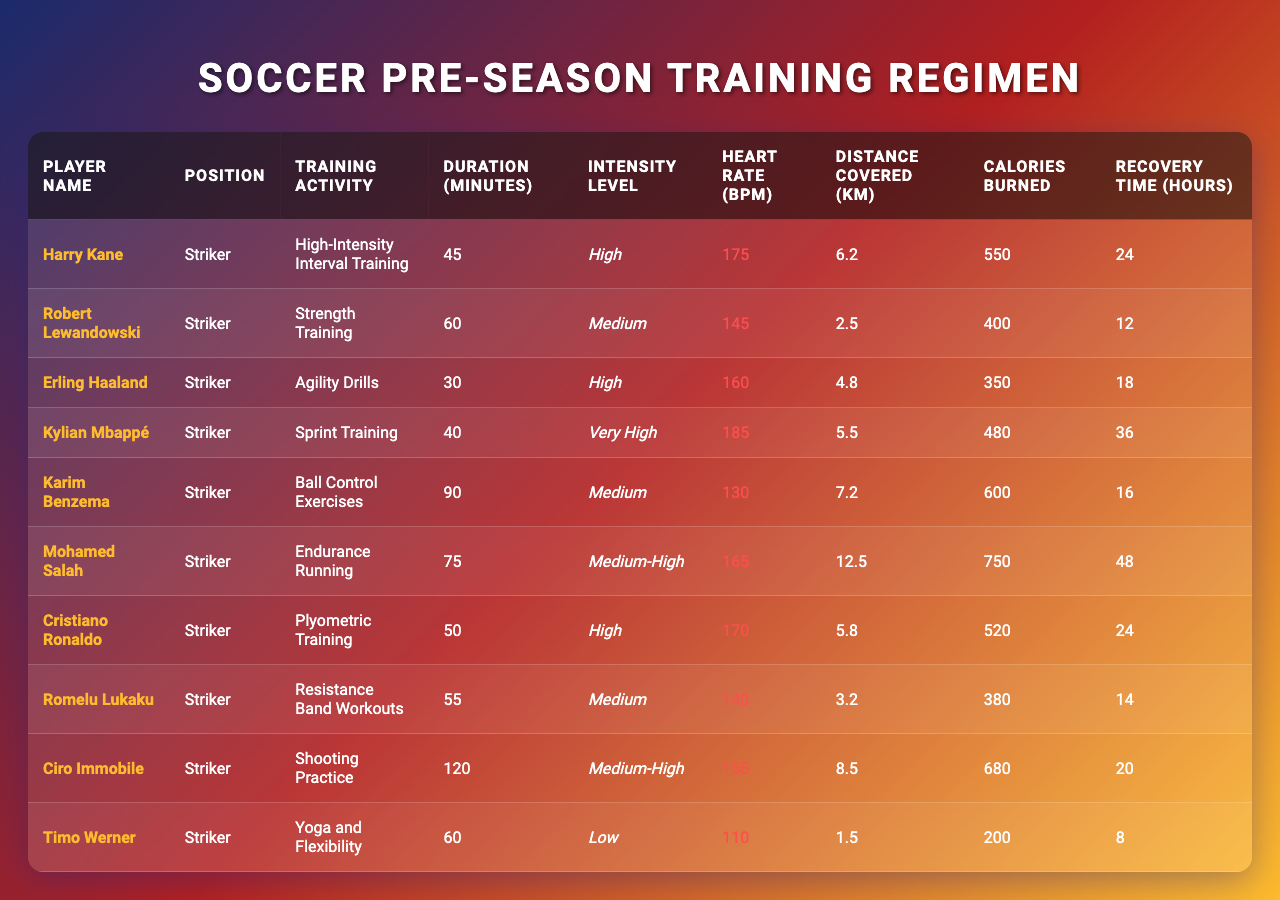What is the duration of training for Kylian Mbappé? The table lists Kylian Mbappé's training duration as 40 minutes, located in the "Duration (minutes)" column for his "Sprint Training."
Answer: 40 Which player has the highest heart rate during training? The table shows Kylian Mbappé with a heart rate of 185 bpm, which is the maximum value in the "Heart Rate (bpm)" column.
Answer: 185 What is the total distance covered by all players combined? Summing the "Distance Covered (km)" for each player (6.2 + 2.5 + 4.8 + 5.5 + 7.2 + 12.5 + 5.8 + 3.2 + 8.5 + 1.5) results in 57.7 km.
Answer: 57.7 Is the recovery time for Mohamed Salah longer than that for Erling Haaland? Mohamed Salah has a recovery time of 48 hours, while Erling Haaland has 18 hours. Since 48 > 18, the statement is true.
Answer: Yes What is the average calories burned among all players? First, calculate the total calories burned: (550 + 400 + 350 + 480 + 600 + 750 + 520 + 380 + 680 + 200) = 4360. Divide this by the number of players (10) to get the average: 4360 / 10 = 436.
Answer: 436 Which training activity has the longest duration? Ciro Immobile's "Shooting Practice" has the longest duration at 120 minutes, the maximum duration found in the "Duration (minutes)" column.
Answer: 120 Is it true that all players have a medium or higher intensity level? Examining the "Intensity Level" column, Kylian Mbappé's "Sprint Training" is "Very High," while Timo Werner's "Yoga and Flexibility" is "Low," so the statement is false.
Answer: No Who covers the least distance during their training? Romelu Lukaku covers the least distance of 3.2 km as per the "Distance Covered (km)" column, the lowest value on the table.
Answer: Romelu Lukaku What is the combined recovery time for both Harry Kane and Cristiano Ronaldo? Harry Kane requires 24 hours for recovery, and Cristiano Ronaldo also needs 24 hours. The combined recovery time is 24 + 24 = 48 hours.
Answer: 48 Which player performs endurance running and how many calories do they burn? The table shows that Mohamed Salah performs "Endurance Running" and he burns 750 calories as indicated in the "Calories Burned" column.
Answer: Mohamed Salah, 750 What is the intensity level for the agility drills performed by Erling Haaland? Erling Haaland's agility drills are listed under the "Intensity Level" column as "High."
Answer: High 